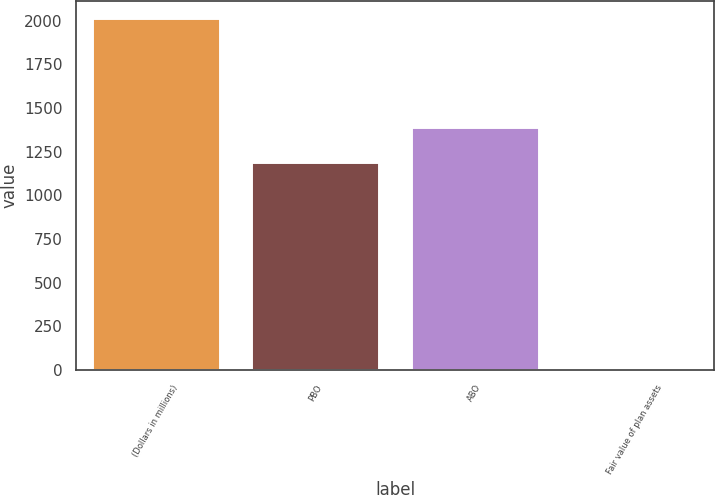Convert chart to OTSL. <chart><loc_0><loc_0><loc_500><loc_500><bar_chart><fcel>(Dollars in millions)<fcel>PBO<fcel>ABO<fcel>Fair value of plan assets<nl><fcel>2014<fcel>1190<fcel>1391.2<fcel>2<nl></chart> 